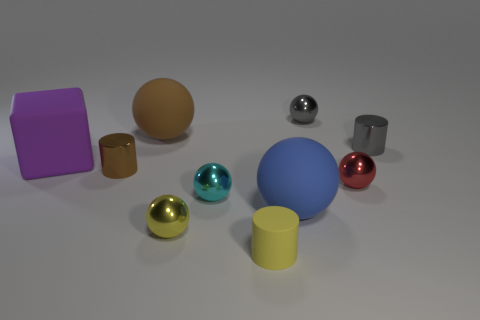Subtract all small cyan metallic balls. How many balls are left? 5 Subtract all cyan balls. How many balls are left? 5 Subtract all purple spheres. Subtract all blue cubes. How many spheres are left? 6 Subtract all cylinders. How many objects are left? 7 Add 4 cyan balls. How many cyan balls exist? 5 Subtract 0 cyan cylinders. How many objects are left? 10 Subtract all metal spheres. Subtract all cyan balls. How many objects are left? 5 Add 7 yellow matte things. How many yellow matte things are left? 8 